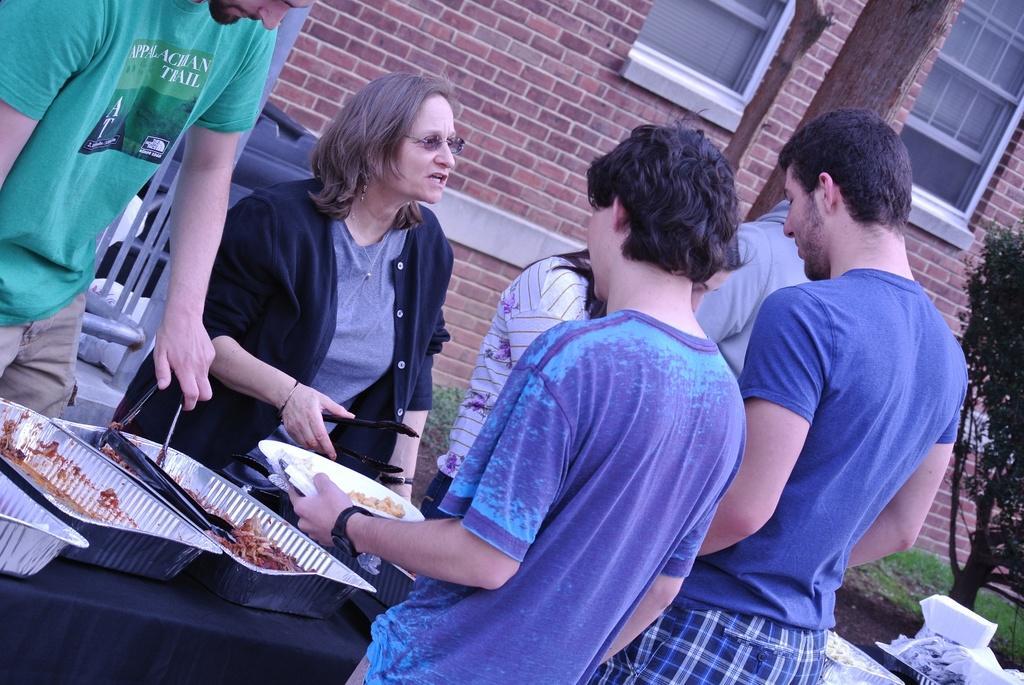Please provide a concise description of this image. In this image we can see the people standing. We can also see a man and a woman holding the tongs. We can also see a person holding the plate. We can see the table which is covered with the black color cloth and on the table we can see the trays of food items. We can see also see some other objects. In the background we can see the building with the windows and also the brick wall. We can also see the plant and also the grass. 